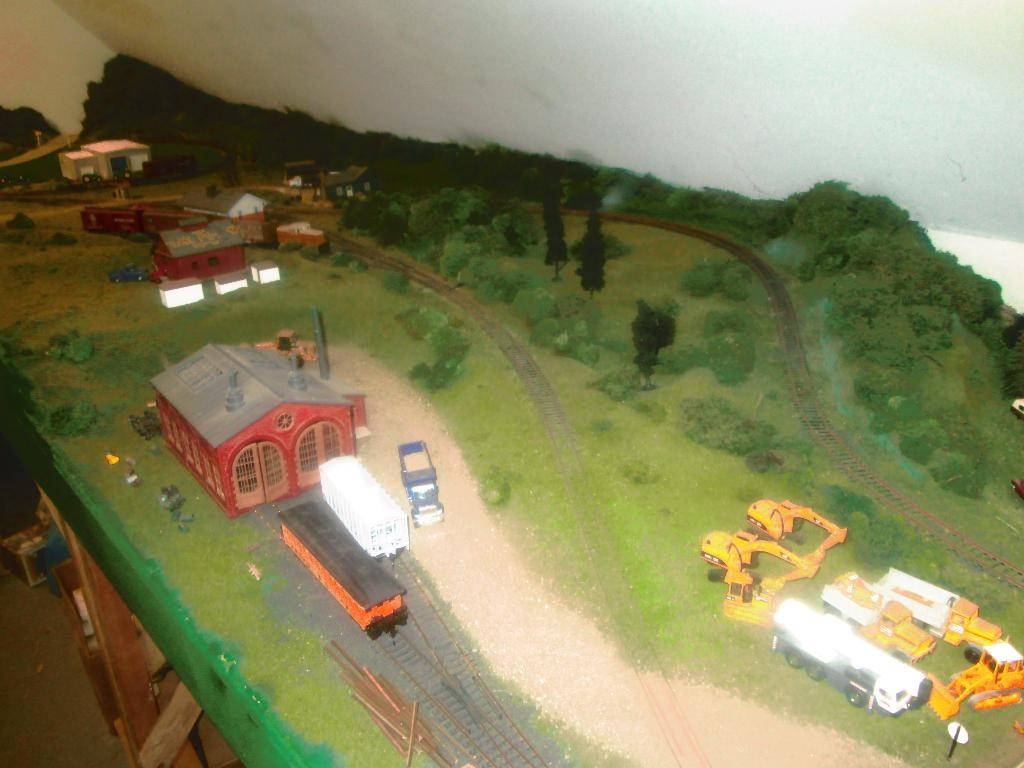What is the main subject of the image? The image contains a sample of a project. What type of structures can be seen in the image? There are houses in the image. What construction equipment is present in the image? Cranes are present in the image. What mode of transportation is visible in the image? Trains are visible on railway tracks in the image. What type of vegetation is present in the image? There are plants and trees in the image. What day of the week is the kitten playing in the image? There is no kitten present in the image, so it is not possible to determine the day of the week. 